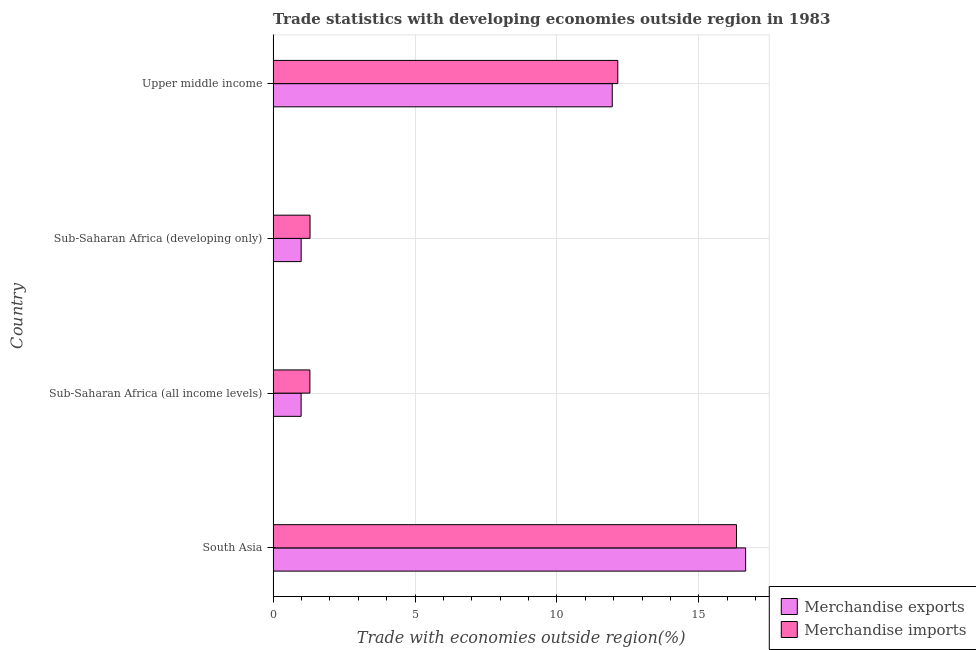How many groups of bars are there?
Your answer should be very brief. 4. Are the number of bars per tick equal to the number of legend labels?
Your answer should be very brief. Yes. How many bars are there on the 3rd tick from the top?
Provide a short and direct response. 2. How many bars are there on the 1st tick from the bottom?
Ensure brevity in your answer.  2. What is the label of the 4th group of bars from the top?
Give a very brief answer. South Asia. In how many cases, is the number of bars for a given country not equal to the number of legend labels?
Offer a terse response. 0. What is the merchandise exports in South Asia?
Provide a succinct answer. 16.65. Across all countries, what is the maximum merchandise exports?
Provide a succinct answer. 16.65. Across all countries, what is the minimum merchandise imports?
Ensure brevity in your answer.  1.3. In which country was the merchandise exports minimum?
Your answer should be very brief. Sub-Saharan Africa (all income levels). What is the total merchandise exports in the graph?
Keep it short and to the point. 30.57. What is the difference between the merchandise imports in Sub-Saharan Africa (all income levels) and that in Upper middle income?
Your answer should be compact. -10.85. What is the difference between the merchandise imports in Sub-Saharan Africa (all income levels) and the merchandise exports in Upper middle income?
Your response must be concise. -10.65. What is the average merchandise imports per country?
Keep it short and to the point. 7.77. What is the difference between the merchandise imports and merchandise exports in Sub-Saharan Africa (developing only)?
Your response must be concise. 0.31. What is the ratio of the merchandise exports in Sub-Saharan Africa (developing only) to that in Upper middle income?
Your answer should be very brief. 0.08. Is the difference between the merchandise imports in Sub-Saharan Africa (all income levels) and Sub-Saharan Africa (developing only) greater than the difference between the merchandise exports in Sub-Saharan Africa (all income levels) and Sub-Saharan Africa (developing only)?
Offer a terse response. No. What is the difference between the highest and the second highest merchandise imports?
Your response must be concise. 4.18. What is the difference between the highest and the lowest merchandise exports?
Your response must be concise. 15.66. Is the sum of the merchandise imports in South Asia and Sub-Saharan Africa (developing only) greater than the maximum merchandise exports across all countries?
Offer a terse response. Yes. How many bars are there?
Make the answer very short. 8. Are all the bars in the graph horizontal?
Make the answer very short. Yes. How many countries are there in the graph?
Offer a terse response. 4. What is the difference between two consecutive major ticks on the X-axis?
Your answer should be very brief. 5. Are the values on the major ticks of X-axis written in scientific E-notation?
Your response must be concise. No. Does the graph contain grids?
Keep it short and to the point. Yes. How are the legend labels stacked?
Your answer should be very brief. Vertical. What is the title of the graph?
Give a very brief answer. Trade statistics with developing economies outside region in 1983. Does "Borrowers" appear as one of the legend labels in the graph?
Your response must be concise. No. What is the label or title of the X-axis?
Ensure brevity in your answer.  Trade with economies outside region(%). What is the label or title of the Y-axis?
Ensure brevity in your answer.  Country. What is the Trade with economies outside region(%) of Merchandise exports in South Asia?
Offer a very short reply. 16.65. What is the Trade with economies outside region(%) of Merchandise imports in South Asia?
Your answer should be very brief. 16.33. What is the Trade with economies outside region(%) of Merchandise exports in Sub-Saharan Africa (all income levels)?
Your answer should be very brief. 0.99. What is the Trade with economies outside region(%) in Merchandise imports in Sub-Saharan Africa (all income levels)?
Offer a very short reply. 1.3. What is the Trade with economies outside region(%) of Merchandise exports in Sub-Saharan Africa (developing only)?
Offer a terse response. 0.99. What is the Trade with economies outside region(%) of Merchandise imports in Sub-Saharan Africa (developing only)?
Provide a succinct answer. 1.3. What is the Trade with economies outside region(%) of Merchandise exports in Upper middle income?
Make the answer very short. 11.95. What is the Trade with economies outside region(%) of Merchandise imports in Upper middle income?
Offer a very short reply. 12.14. Across all countries, what is the maximum Trade with economies outside region(%) of Merchandise exports?
Provide a short and direct response. 16.65. Across all countries, what is the maximum Trade with economies outside region(%) in Merchandise imports?
Your answer should be very brief. 16.33. Across all countries, what is the minimum Trade with economies outside region(%) in Merchandise exports?
Your answer should be compact. 0.99. Across all countries, what is the minimum Trade with economies outside region(%) of Merchandise imports?
Your answer should be very brief. 1.3. What is the total Trade with economies outside region(%) of Merchandise exports in the graph?
Your answer should be very brief. 30.57. What is the total Trade with economies outside region(%) of Merchandise imports in the graph?
Your response must be concise. 31.07. What is the difference between the Trade with economies outside region(%) in Merchandise exports in South Asia and that in Sub-Saharan Africa (all income levels)?
Your answer should be very brief. 15.66. What is the difference between the Trade with economies outside region(%) of Merchandise imports in South Asia and that in Sub-Saharan Africa (all income levels)?
Provide a succinct answer. 15.03. What is the difference between the Trade with economies outside region(%) in Merchandise exports in South Asia and that in Sub-Saharan Africa (developing only)?
Your response must be concise. 15.66. What is the difference between the Trade with economies outside region(%) of Merchandise imports in South Asia and that in Sub-Saharan Africa (developing only)?
Ensure brevity in your answer.  15.03. What is the difference between the Trade with economies outside region(%) of Merchandise exports in South Asia and that in Upper middle income?
Offer a terse response. 4.7. What is the difference between the Trade with economies outside region(%) in Merchandise imports in South Asia and that in Upper middle income?
Your response must be concise. 4.18. What is the difference between the Trade with economies outside region(%) in Merchandise exports in Sub-Saharan Africa (all income levels) and that in Sub-Saharan Africa (developing only)?
Ensure brevity in your answer.  -0. What is the difference between the Trade with economies outside region(%) of Merchandise imports in Sub-Saharan Africa (all income levels) and that in Sub-Saharan Africa (developing only)?
Offer a terse response. -0. What is the difference between the Trade with economies outside region(%) in Merchandise exports in Sub-Saharan Africa (all income levels) and that in Upper middle income?
Ensure brevity in your answer.  -10.96. What is the difference between the Trade with economies outside region(%) of Merchandise imports in Sub-Saharan Africa (all income levels) and that in Upper middle income?
Offer a very short reply. -10.85. What is the difference between the Trade with economies outside region(%) in Merchandise exports in Sub-Saharan Africa (developing only) and that in Upper middle income?
Provide a succinct answer. -10.96. What is the difference between the Trade with economies outside region(%) in Merchandise imports in Sub-Saharan Africa (developing only) and that in Upper middle income?
Offer a very short reply. -10.84. What is the difference between the Trade with economies outside region(%) of Merchandise exports in South Asia and the Trade with economies outside region(%) of Merchandise imports in Sub-Saharan Africa (all income levels)?
Make the answer very short. 15.35. What is the difference between the Trade with economies outside region(%) in Merchandise exports in South Asia and the Trade with economies outside region(%) in Merchandise imports in Sub-Saharan Africa (developing only)?
Your answer should be very brief. 15.35. What is the difference between the Trade with economies outside region(%) of Merchandise exports in South Asia and the Trade with economies outside region(%) of Merchandise imports in Upper middle income?
Provide a short and direct response. 4.5. What is the difference between the Trade with economies outside region(%) in Merchandise exports in Sub-Saharan Africa (all income levels) and the Trade with economies outside region(%) in Merchandise imports in Sub-Saharan Africa (developing only)?
Your response must be concise. -0.31. What is the difference between the Trade with economies outside region(%) in Merchandise exports in Sub-Saharan Africa (all income levels) and the Trade with economies outside region(%) in Merchandise imports in Upper middle income?
Make the answer very short. -11.16. What is the difference between the Trade with economies outside region(%) in Merchandise exports in Sub-Saharan Africa (developing only) and the Trade with economies outside region(%) in Merchandise imports in Upper middle income?
Give a very brief answer. -11.16. What is the average Trade with economies outside region(%) of Merchandise exports per country?
Keep it short and to the point. 7.64. What is the average Trade with economies outside region(%) of Merchandise imports per country?
Provide a succinct answer. 7.77. What is the difference between the Trade with economies outside region(%) of Merchandise exports and Trade with economies outside region(%) of Merchandise imports in South Asia?
Ensure brevity in your answer.  0.32. What is the difference between the Trade with economies outside region(%) in Merchandise exports and Trade with economies outside region(%) in Merchandise imports in Sub-Saharan Africa (all income levels)?
Keep it short and to the point. -0.31. What is the difference between the Trade with economies outside region(%) of Merchandise exports and Trade with economies outside region(%) of Merchandise imports in Sub-Saharan Africa (developing only)?
Offer a very short reply. -0.31. What is the difference between the Trade with economies outside region(%) of Merchandise exports and Trade with economies outside region(%) of Merchandise imports in Upper middle income?
Provide a short and direct response. -0.2. What is the ratio of the Trade with economies outside region(%) of Merchandise exports in South Asia to that in Sub-Saharan Africa (all income levels)?
Your answer should be very brief. 16.87. What is the ratio of the Trade with economies outside region(%) of Merchandise imports in South Asia to that in Sub-Saharan Africa (all income levels)?
Your response must be concise. 12.6. What is the ratio of the Trade with economies outside region(%) of Merchandise exports in South Asia to that in Sub-Saharan Africa (developing only)?
Your answer should be very brief. 16.85. What is the ratio of the Trade with economies outside region(%) of Merchandise imports in South Asia to that in Sub-Saharan Africa (developing only)?
Your answer should be compact. 12.55. What is the ratio of the Trade with economies outside region(%) of Merchandise exports in South Asia to that in Upper middle income?
Give a very brief answer. 1.39. What is the ratio of the Trade with economies outside region(%) in Merchandise imports in South Asia to that in Upper middle income?
Offer a very short reply. 1.34. What is the ratio of the Trade with economies outside region(%) in Merchandise imports in Sub-Saharan Africa (all income levels) to that in Sub-Saharan Africa (developing only)?
Make the answer very short. 1. What is the ratio of the Trade with economies outside region(%) in Merchandise exports in Sub-Saharan Africa (all income levels) to that in Upper middle income?
Your response must be concise. 0.08. What is the ratio of the Trade with economies outside region(%) of Merchandise imports in Sub-Saharan Africa (all income levels) to that in Upper middle income?
Make the answer very short. 0.11. What is the ratio of the Trade with economies outside region(%) in Merchandise exports in Sub-Saharan Africa (developing only) to that in Upper middle income?
Give a very brief answer. 0.08. What is the ratio of the Trade with economies outside region(%) of Merchandise imports in Sub-Saharan Africa (developing only) to that in Upper middle income?
Your answer should be very brief. 0.11. What is the difference between the highest and the second highest Trade with economies outside region(%) of Merchandise exports?
Give a very brief answer. 4.7. What is the difference between the highest and the second highest Trade with economies outside region(%) of Merchandise imports?
Your response must be concise. 4.18. What is the difference between the highest and the lowest Trade with economies outside region(%) in Merchandise exports?
Provide a succinct answer. 15.66. What is the difference between the highest and the lowest Trade with economies outside region(%) of Merchandise imports?
Make the answer very short. 15.03. 